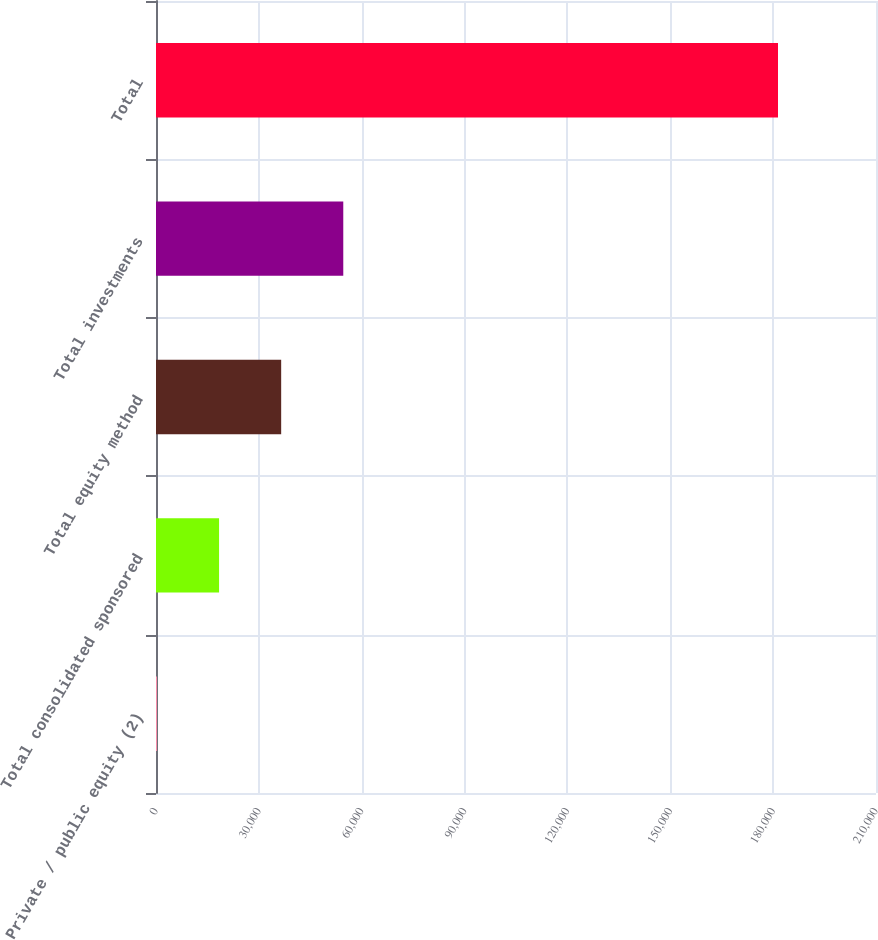<chart> <loc_0><loc_0><loc_500><loc_500><bar_chart><fcel>Private / public equity (2)<fcel>Total consolidated sponsored<fcel>Total equity method<fcel>Total investments<fcel>Total<nl><fcel>282<fcel>18395.4<fcel>36508.8<fcel>54622.2<fcel>181416<nl></chart> 